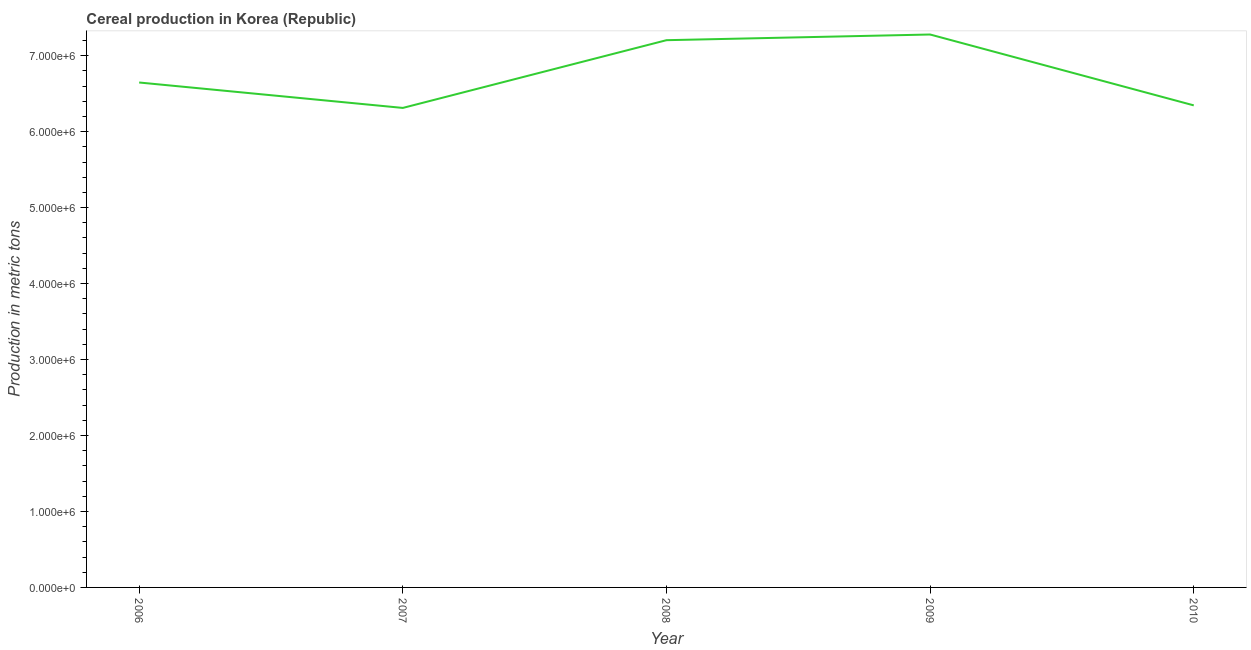What is the cereal production in 2008?
Offer a terse response. 7.20e+06. Across all years, what is the maximum cereal production?
Give a very brief answer. 7.28e+06. Across all years, what is the minimum cereal production?
Ensure brevity in your answer.  6.31e+06. In which year was the cereal production maximum?
Give a very brief answer. 2009. What is the sum of the cereal production?
Your answer should be very brief. 3.38e+07. What is the difference between the cereal production in 2007 and 2009?
Provide a short and direct response. -9.67e+05. What is the average cereal production per year?
Offer a very short reply. 6.76e+06. What is the median cereal production?
Offer a terse response. 6.65e+06. Do a majority of the years between 2006 and 2007 (inclusive) have cereal production greater than 1600000 metric tons?
Your answer should be compact. Yes. What is the ratio of the cereal production in 2006 to that in 2007?
Ensure brevity in your answer.  1.05. Is the cereal production in 2008 less than that in 2010?
Keep it short and to the point. No. What is the difference between the highest and the second highest cereal production?
Make the answer very short. 7.50e+04. Is the sum of the cereal production in 2007 and 2010 greater than the maximum cereal production across all years?
Provide a short and direct response. Yes. What is the difference between the highest and the lowest cereal production?
Offer a terse response. 9.67e+05. In how many years, is the cereal production greater than the average cereal production taken over all years?
Offer a terse response. 2. Does the cereal production monotonically increase over the years?
Your answer should be compact. No. How many lines are there?
Your response must be concise. 1. Are the values on the major ticks of Y-axis written in scientific E-notation?
Make the answer very short. Yes. Does the graph contain any zero values?
Keep it short and to the point. No. What is the title of the graph?
Provide a short and direct response. Cereal production in Korea (Republic). What is the label or title of the X-axis?
Your answer should be very brief. Year. What is the label or title of the Y-axis?
Your answer should be very brief. Production in metric tons. What is the Production in metric tons of 2006?
Make the answer very short. 6.65e+06. What is the Production in metric tons of 2007?
Offer a terse response. 6.31e+06. What is the Production in metric tons of 2008?
Your answer should be compact. 7.20e+06. What is the Production in metric tons in 2009?
Give a very brief answer. 7.28e+06. What is the Production in metric tons in 2010?
Your response must be concise. 6.35e+06. What is the difference between the Production in metric tons in 2006 and 2007?
Keep it short and to the point. 3.35e+05. What is the difference between the Production in metric tons in 2006 and 2008?
Provide a succinct answer. -5.57e+05. What is the difference between the Production in metric tons in 2006 and 2009?
Your answer should be compact. -6.32e+05. What is the difference between the Production in metric tons in 2006 and 2010?
Give a very brief answer. 3.01e+05. What is the difference between the Production in metric tons in 2007 and 2008?
Provide a succinct answer. -8.92e+05. What is the difference between the Production in metric tons in 2007 and 2009?
Provide a succinct answer. -9.67e+05. What is the difference between the Production in metric tons in 2007 and 2010?
Give a very brief answer. -3.36e+04. What is the difference between the Production in metric tons in 2008 and 2009?
Your answer should be very brief. -7.50e+04. What is the difference between the Production in metric tons in 2008 and 2010?
Ensure brevity in your answer.  8.58e+05. What is the difference between the Production in metric tons in 2009 and 2010?
Keep it short and to the point. 9.33e+05. What is the ratio of the Production in metric tons in 2006 to that in 2007?
Offer a terse response. 1.05. What is the ratio of the Production in metric tons in 2006 to that in 2008?
Your response must be concise. 0.92. What is the ratio of the Production in metric tons in 2006 to that in 2010?
Your response must be concise. 1.05. What is the ratio of the Production in metric tons in 2007 to that in 2008?
Keep it short and to the point. 0.88. What is the ratio of the Production in metric tons in 2007 to that in 2009?
Provide a succinct answer. 0.87. What is the ratio of the Production in metric tons in 2008 to that in 2009?
Make the answer very short. 0.99. What is the ratio of the Production in metric tons in 2008 to that in 2010?
Keep it short and to the point. 1.14. What is the ratio of the Production in metric tons in 2009 to that in 2010?
Offer a terse response. 1.15. 